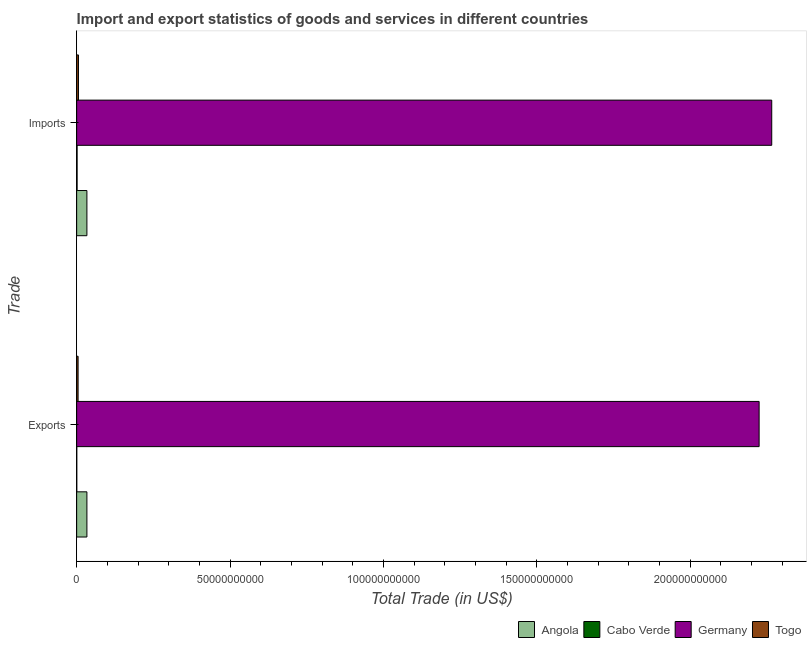Are the number of bars per tick equal to the number of legend labels?
Offer a very short reply. Yes. Are the number of bars on each tick of the Y-axis equal?
Your answer should be very brief. Yes. What is the label of the 2nd group of bars from the top?
Your answer should be compact. Exports. What is the imports of goods and services in Togo?
Offer a terse response. 5.91e+08. Across all countries, what is the maximum export of goods and services?
Your answer should be compact. 2.22e+11. Across all countries, what is the minimum imports of goods and services?
Your answer should be compact. 1.44e+08. In which country was the export of goods and services minimum?
Keep it short and to the point. Cabo Verde. What is the total export of goods and services in the graph?
Keep it short and to the point. 2.26e+11. What is the difference between the imports of goods and services in Germany and that in Togo?
Make the answer very short. 2.26e+11. What is the difference between the export of goods and services in Cabo Verde and the imports of goods and services in Angola?
Your answer should be very brief. -3.31e+09. What is the average export of goods and services per country?
Your response must be concise. 5.66e+1. What is the difference between the imports of goods and services and export of goods and services in Togo?
Make the answer very short. 1.24e+08. What is the ratio of the export of goods and services in Togo to that in Angola?
Offer a very short reply. 0.14. What does the 2nd bar from the top in Exports represents?
Your answer should be compact. Germany. What does the 4th bar from the bottom in Imports represents?
Offer a very short reply. Togo. How many bars are there?
Make the answer very short. 8. What is the difference between two consecutive major ticks on the X-axis?
Make the answer very short. 5.00e+1. Does the graph contain any zero values?
Ensure brevity in your answer.  No. Where does the legend appear in the graph?
Your answer should be very brief. Bottom right. How many legend labels are there?
Your answer should be compact. 4. What is the title of the graph?
Offer a very short reply. Import and export statistics of goods and services in different countries. What is the label or title of the X-axis?
Your response must be concise. Total Trade (in US$). What is the label or title of the Y-axis?
Offer a very short reply. Trade. What is the Total Trade (in US$) in Angola in Exports?
Your response must be concise. 3.34e+09. What is the Total Trade (in US$) of Cabo Verde in Exports?
Provide a short and direct response. 3.36e+07. What is the Total Trade (in US$) in Germany in Exports?
Your response must be concise. 2.22e+11. What is the Total Trade (in US$) of Togo in Exports?
Give a very brief answer. 4.67e+08. What is the Total Trade (in US$) of Angola in Imports?
Provide a short and direct response. 3.34e+09. What is the Total Trade (in US$) of Cabo Verde in Imports?
Provide a succinct answer. 1.44e+08. What is the Total Trade (in US$) in Germany in Imports?
Keep it short and to the point. 2.27e+11. What is the Total Trade (in US$) of Togo in Imports?
Give a very brief answer. 5.91e+08. Across all Trade, what is the maximum Total Trade (in US$) in Angola?
Offer a terse response. 3.34e+09. Across all Trade, what is the maximum Total Trade (in US$) of Cabo Verde?
Offer a terse response. 1.44e+08. Across all Trade, what is the maximum Total Trade (in US$) of Germany?
Ensure brevity in your answer.  2.27e+11. Across all Trade, what is the maximum Total Trade (in US$) of Togo?
Offer a very short reply. 5.91e+08. Across all Trade, what is the minimum Total Trade (in US$) in Angola?
Your answer should be compact. 3.34e+09. Across all Trade, what is the minimum Total Trade (in US$) of Cabo Verde?
Ensure brevity in your answer.  3.36e+07. Across all Trade, what is the minimum Total Trade (in US$) of Germany?
Your answer should be compact. 2.22e+11. Across all Trade, what is the minimum Total Trade (in US$) of Togo?
Ensure brevity in your answer.  4.67e+08. What is the total Total Trade (in US$) in Angola in the graph?
Your answer should be compact. 6.68e+09. What is the total Total Trade (in US$) in Cabo Verde in the graph?
Your response must be concise. 1.77e+08. What is the total Total Trade (in US$) in Germany in the graph?
Offer a very short reply. 4.49e+11. What is the total Total Trade (in US$) of Togo in the graph?
Give a very brief answer. 1.06e+09. What is the difference between the Total Trade (in US$) of Cabo Verde in Exports and that in Imports?
Provide a short and direct response. -1.10e+08. What is the difference between the Total Trade (in US$) in Germany in Exports and that in Imports?
Make the answer very short. -4.11e+09. What is the difference between the Total Trade (in US$) of Togo in Exports and that in Imports?
Ensure brevity in your answer.  -1.24e+08. What is the difference between the Total Trade (in US$) in Angola in Exports and the Total Trade (in US$) in Cabo Verde in Imports?
Keep it short and to the point. 3.20e+09. What is the difference between the Total Trade (in US$) in Angola in Exports and the Total Trade (in US$) in Germany in Imports?
Give a very brief answer. -2.23e+11. What is the difference between the Total Trade (in US$) in Angola in Exports and the Total Trade (in US$) in Togo in Imports?
Your answer should be compact. 2.75e+09. What is the difference between the Total Trade (in US$) of Cabo Verde in Exports and the Total Trade (in US$) of Germany in Imports?
Make the answer very short. -2.27e+11. What is the difference between the Total Trade (in US$) in Cabo Verde in Exports and the Total Trade (in US$) in Togo in Imports?
Give a very brief answer. -5.57e+08. What is the difference between the Total Trade (in US$) of Germany in Exports and the Total Trade (in US$) of Togo in Imports?
Offer a terse response. 2.22e+11. What is the average Total Trade (in US$) of Angola per Trade?
Provide a succinct answer. 3.34e+09. What is the average Total Trade (in US$) of Cabo Verde per Trade?
Your response must be concise. 8.87e+07. What is the average Total Trade (in US$) in Germany per Trade?
Give a very brief answer. 2.25e+11. What is the average Total Trade (in US$) of Togo per Trade?
Your response must be concise. 5.29e+08. What is the difference between the Total Trade (in US$) in Angola and Total Trade (in US$) in Cabo Verde in Exports?
Offer a terse response. 3.31e+09. What is the difference between the Total Trade (in US$) of Angola and Total Trade (in US$) of Germany in Exports?
Keep it short and to the point. -2.19e+11. What is the difference between the Total Trade (in US$) of Angola and Total Trade (in US$) of Togo in Exports?
Your response must be concise. 2.88e+09. What is the difference between the Total Trade (in US$) in Cabo Verde and Total Trade (in US$) in Germany in Exports?
Give a very brief answer. -2.22e+11. What is the difference between the Total Trade (in US$) in Cabo Verde and Total Trade (in US$) in Togo in Exports?
Make the answer very short. -4.33e+08. What is the difference between the Total Trade (in US$) in Germany and Total Trade (in US$) in Togo in Exports?
Make the answer very short. 2.22e+11. What is the difference between the Total Trade (in US$) of Angola and Total Trade (in US$) of Cabo Verde in Imports?
Offer a terse response. 3.20e+09. What is the difference between the Total Trade (in US$) in Angola and Total Trade (in US$) in Germany in Imports?
Ensure brevity in your answer.  -2.23e+11. What is the difference between the Total Trade (in US$) in Angola and Total Trade (in US$) in Togo in Imports?
Offer a terse response. 2.75e+09. What is the difference between the Total Trade (in US$) of Cabo Verde and Total Trade (in US$) of Germany in Imports?
Ensure brevity in your answer.  -2.26e+11. What is the difference between the Total Trade (in US$) of Cabo Verde and Total Trade (in US$) of Togo in Imports?
Provide a short and direct response. -4.47e+08. What is the difference between the Total Trade (in US$) of Germany and Total Trade (in US$) of Togo in Imports?
Offer a terse response. 2.26e+11. What is the ratio of the Total Trade (in US$) of Angola in Exports to that in Imports?
Give a very brief answer. 1. What is the ratio of the Total Trade (in US$) in Cabo Verde in Exports to that in Imports?
Provide a succinct answer. 0.23. What is the ratio of the Total Trade (in US$) in Germany in Exports to that in Imports?
Ensure brevity in your answer.  0.98. What is the ratio of the Total Trade (in US$) in Togo in Exports to that in Imports?
Make the answer very short. 0.79. What is the difference between the highest and the second highest Total Trade (in US$) of Cabo Verde?
Provide a succinct answer. 1.10e+08. What is the difference between the highest and the second highest Total Trade (in US$) of Germany?
Provide a succinct answer. 4.11e+09. What is the difference between the highest and the second highest Total Trade (in US$) in Togo?
Ensure brevity in your answer.  1.24e+08. What is the difference between the highest and the lowest Total Trade (in US$) in Angola?
Your answer should be compact. 0. What is the difference between the highest and the lowest Total Trade (in US$) of Cabo Verde?
Keep it short and to the point. 1.10e+08. What is the difference between the highest and the lowest Total Trade (in US$) in Germany?
Offer a very short reply. 4.11e+09. What is the difference between the highest and the lowest Total Trade (in US$) of Togo?
Make the answer very short. 1.24e+08. 